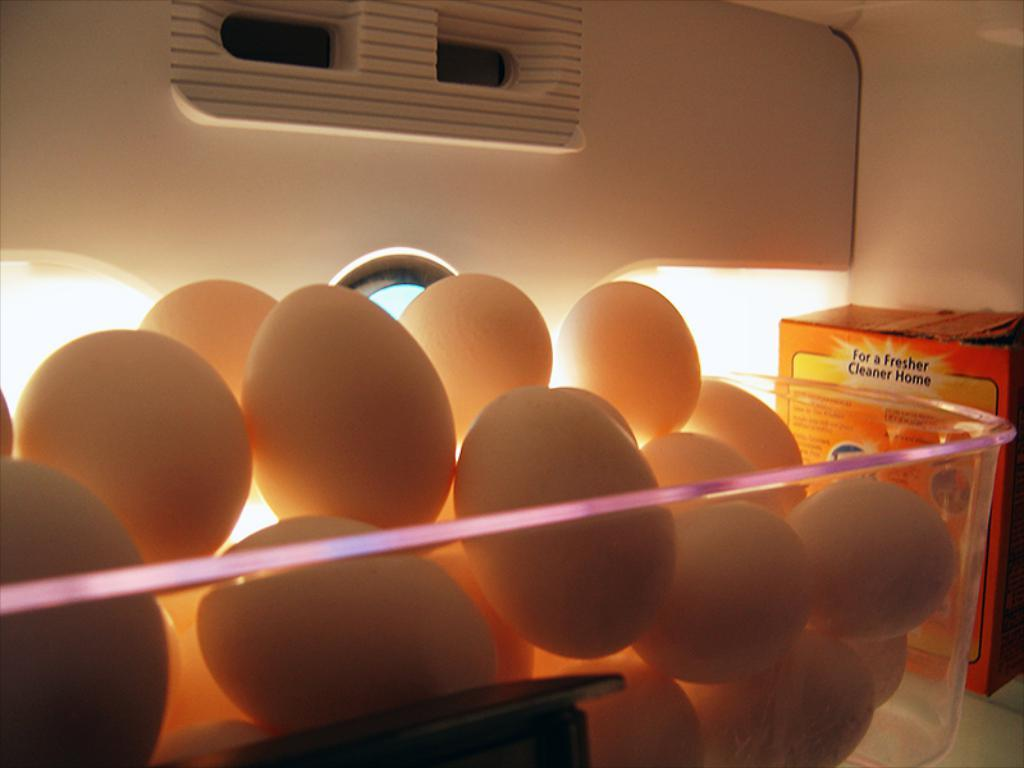What is the setting of the image? The image is of the inside of a fridge. What can be found in the bowl inside the fridge? There are eggs in a bowl in the fridge. What is located beside the bowl in the fridge? There is a box beside the bowl in the fridge. What is providing illumination in the fridge? There are lights visible behind the eggs in the fridge. What type of liquid is being stored in the fridge beside the eggs? There is no liquid visible in the image; it only shows eggs in a bowl and a box beside it. 